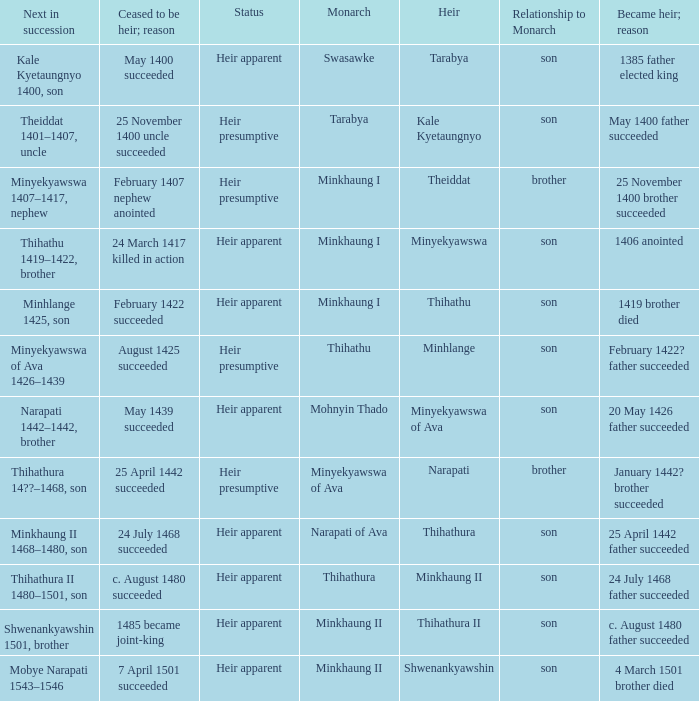What was the relationship to monarch of the heir Minyekyawswa? Son. 